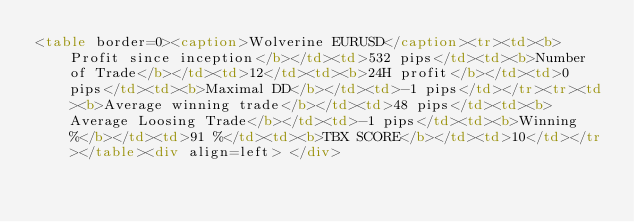Convert code to text. <code><loc_0><loc_0><loc_500><loc_500><_HTML_><table border=0><caption>Wolverine EURUSD</caption><tr><td><b>Profit since inception</b></td><td>532 pips</td><td><b>Number of Trade</b></td><td>12</td><td><b>24H profit</b></td><td>0 pips</td><td><b>Maximal DD</b></td><td>-1 pips</td></tr><tr><td><b>Average winning trade</b></td><td>48 pips</td><td><b>Average Loosing Trade</b></td><td>-1 pips</td><td><b>Winning %</b></td><td>91 %</td><td><b>TBX SCORE</b></td><td>10</td></tr></table><div align=left> </div></code> 